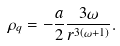<formula> <loc_0><loc_0><loc_500><loc_500>\rho _ { q } = - \frac { a } { 2 } \frac { 3 \omega } { r ^ { 3 ( \omega + 1 ) } } .</formula> 